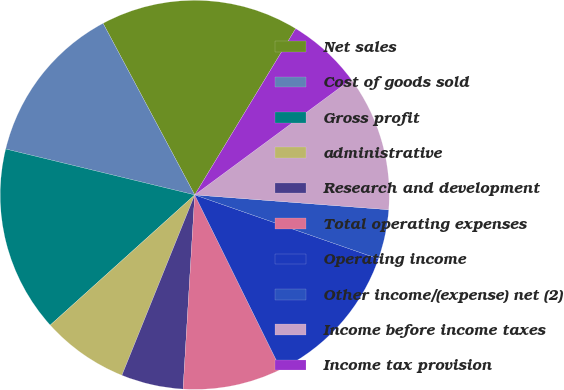<chart> <loc_0><loc_0><loc_500><loc_500><pie_chart><fcel>Net sales<fcel>Cost of goods sold<fcel>Gross profit<fcel>administrative<fcel>Research and development<fcel>Total operating expenses<fcel>Operating income<fcel>Other income/(expense) net (2)<fcel>Income before income taxes<fcel>Income tax provision<nl><fcel>16.49%<fcel>13.4%<fcel>15.46%<fcel>7.22%<fcel>5.15%<fcel>8.25%<fcel>12.37%<fcel>4.12%<fcel>11.34%<fcel>6.19%<nl></chart> 